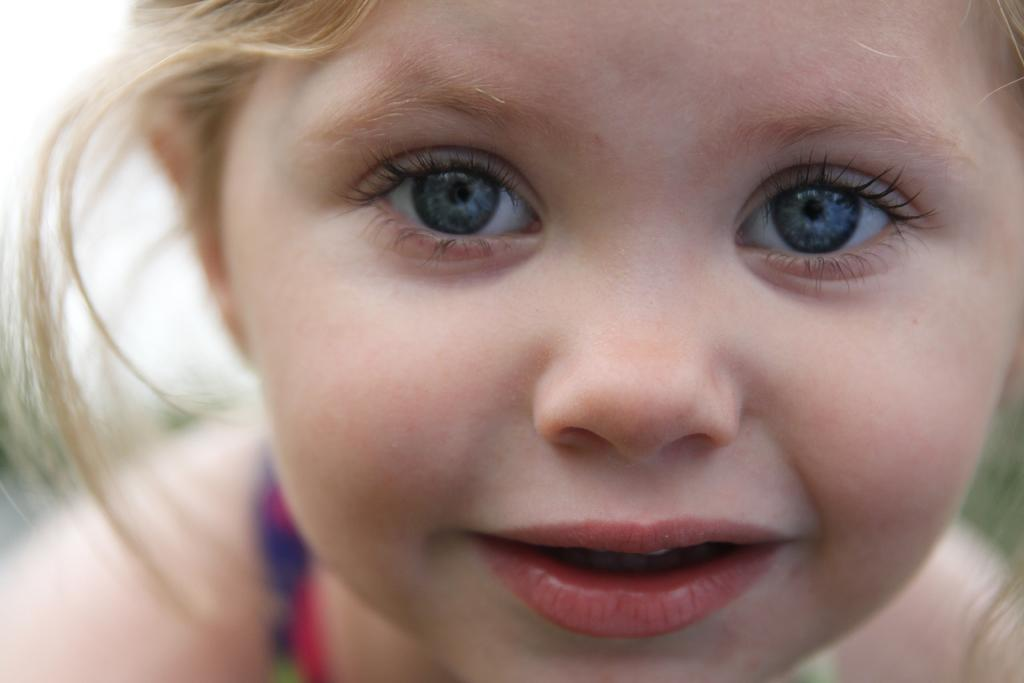Who is the main subject in the image? There is a girl in the image. What is the girl wearing? The girl is wearing a t-shirt. What is the girl's facial expression in the image? The girl is smiling. What can be seen in the top left corner of the image? There is sky visible in the top left of the image. What might be the background on the right side of the image? The background on the right side of the image might be grass. How many pizzas are being delivered to the girl in the image? There are no pizzas present in the image. 